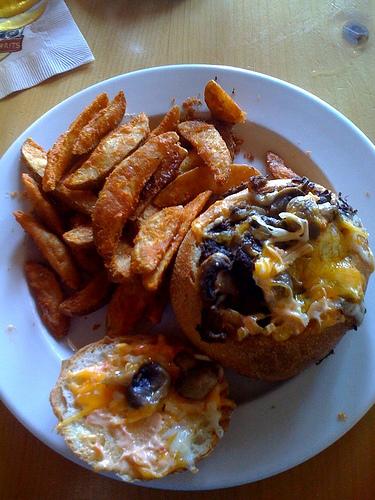What color is the plate?
Answer briefly. White. Where is a napkin?
Short answer required. Top left corner. Are those sweet potato fries or white potato fries?
Short answer required. White. Is the plate empty?
Answer briefly. No. 